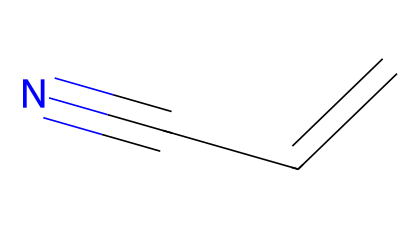How many carbon atoms are present in acrylonitrile? The SMILES representation shows "C=CC#N," indicating there are three carbon atoms in total (one from each "C" and the double bond as well as the carbon involved in the triple bond).
Answer: three What type of bond exists between the second and third carbon atoms? In the structure "C=CC#N," the notation "C#N" indicates a triple bond between the second carbon and the nitrogen atom, which is characteristic of nitriles.
Answer: triple What is the functional group of acrylonitrile? Analyzing the structure "C=CC#N," the presence of a carbon atom triple-bonded to a nitrogen atom indicates the presence of a cyano group (-C≡N), which is the defining feature of nitriles.
Answer: cyano How many total bonds are in the acrylonitrile molecule? The SMILES representation "C=CC#N" contains a double bond (between the first and second carbon) and a triple bond (between the second carbon and nitrogen), leading to a total of four bonds (2 single, 1 double, and 1 triple).
Answer: four What type of chemical is acrylonitrile classified as? Since acrylonitrile contains a cyano group and is derived from alkenes, it is categorized as a nitrile, a subclass of organic compounds. The presence of the triple bond to nitrogen confirms this classification.
Answer: nitrile What is the total number of hydrogen atoms attached to acrylonitrile? In the structure "C=CC#N," there is one hydrogen atom on the first carbon (due to the double bond), two on the second carbon (single bond), and no hydrogen on the third carbon because of the triple bond with nitrogen. Thus, there are a total of three hydrogen atoms.
Answer: three 